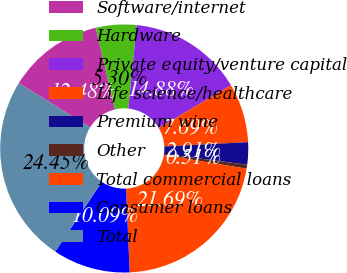<chart> <loc_0><loc_0><loc_500><loc_500><pie_chart><fcel>Software/internet<fcel>Hardware<fcel>Private equity/venture capital<fcel>Life science/healthcare<fcel>Premium wine<fcel>Other<fcel>Total commercial loans<fcel>Consumer loans<fcel>Total<nl><fcel>12.48%<fcel>5.3%<fcel>14.88%<fcel>7.69%<fcel>2.91%<fcel>0.51%<fcel>21.69%<fcel>10.09%<fcel>24.45%<nl></chart> 